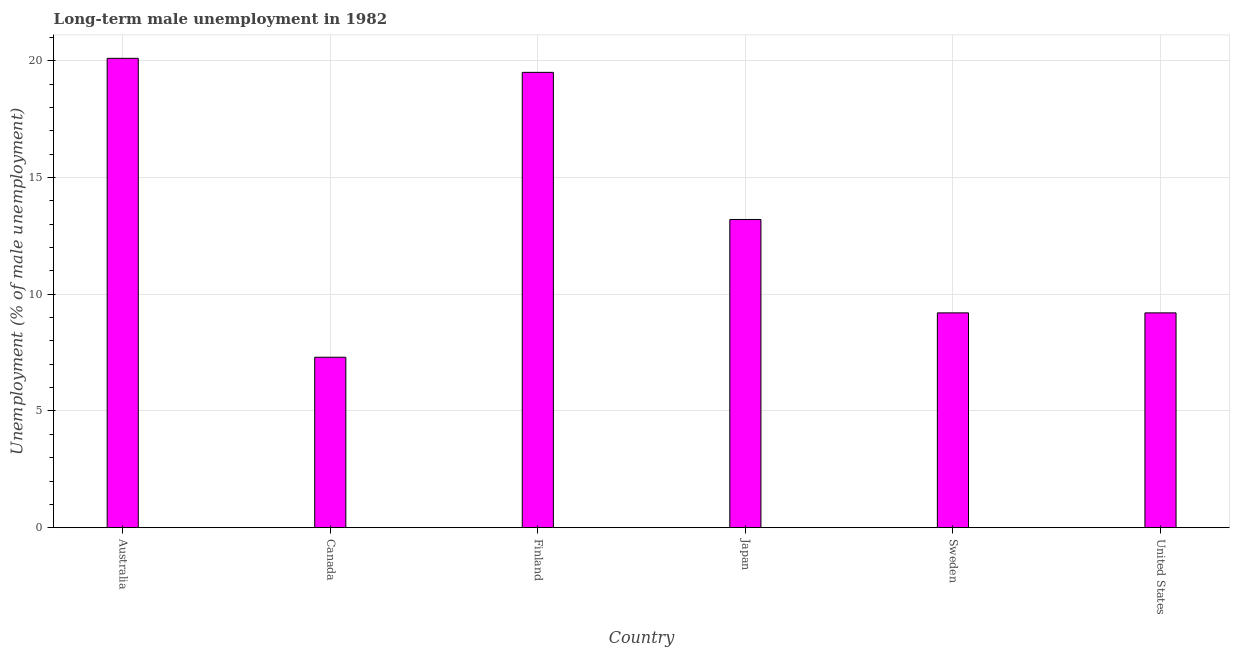What is the title of the graph?
Your answer should be compact. Long-term male unemployment in 1982. What is the label or title of the X-axis?
Provide a succinct answer. Country. What is the label or title of the Y-axis?
Your answer should be compact. Unemployment (% of male unemployment). What is the long-term male unemployment in Sweden?
Offer a terse response. 9.2. Across all countries, what is the maximum long-term male unemployment?
Provide a succinct answer. 20.1. Across all countries, what is the minimum long-term male unemployment?
Your answer should be very brief. 7.3. In which country was the long-term male unemployment maximum?
Offer a terse response. Australia. What is the sum of the long-term male unemployment?
Give a very brief answer. 78.5. What is the difference between the long-term male unemployment in Australia and Japan?
Ensure brevity in your answer.  6.9. What is the average long-term male unemployment per country?
Make the answer very short. 13.08. What is the median long-term male unemployment?
Your answer should be very brief. 11.2. What is the ratio of the long-term male unemployment in Canada to that in Japan?
Give a very brief answer. 0.55. Is the long-term male unemployment in Canada less than that in United States?
Your answer should be very brief. Yes. Is the difference between the long-term male unemployment in Australia and Finland greater than the difference between any two countries?
Offer a terse response. No. What is the difference between the highest and the second highest long-term male unemployment?
Provide a short and direct response. 0.6. Is the sum of the long-term male unemployment in Finland and Sweden greater than the maximum long-term male unemployment across all countries?
Offer a terse response. Yes. In how many countries, is the long-term male unemployment greater than the average long-term male unemployment taken over all countries?
Give a very brief answer. 3. How many bars are there?
Offer a very short reply. 6. Are all the bars in the graph horizontal?
Provide a short and direct response. No. What is the Unemployment (% of male unemployment) in Australia?
Your answer should be very brief. 20.1. What is the Unemployment (% of male unemployment) of Canada?
Keep it short and to the point. 7.3. What is the Unemployment (% of male unemployment) in Japan?
Your response must be concise. 13.2. What is the Unemployment (% of male unemployment) of Sweden?
Offer a terse response. 9.2. What is the Unemployment (% of male unemployment) of United States?
Provide a succinct answer. 9.2. What is the difference between the Unemployment (% of male unemployment) in Australia and Canada?
Make the answer very short. 12.8. What is the difference between the Unemployment (% of male unemployment) in Australia and Finland?
Provide a succinct answer. 0.6. What is the difference between the Unemployment (% of male unemployment) in Canada and Finland?
Keep it short and to the point. -12.2. What is the difference between the Unemployment (% of male unemployment) in Canada and Japan?
Make the answer very short. -5.9. What is the difference between the Unemployment (% of male unemployment) in Finland and Japan?
Offer a very short reply. 6.3. What is the difference between the Unemployment (% of male unemployment) in Finland and Sweden?
Offer a terse response. 10.3. What is the difference between the Unemployment (% of male unemployment) in Japan and Sweden?
Offer a very short reply. 4. What is the difference between the Unemployment (% of male unemployment) in Japan and United States?
Provide a short and direct response. 4. What is the ratio of the Unemployment (% of male unemployment) in Australia to that in Canada?
Provide a short and direct response. 2.75. What is the ratio of the Unemployment (% of male unemployment) in Australia to that in Finland?
Your response must be concise. 1.03. What is the ratio of the Unemployment (% of male unemployment) in Australia to that in Japan?
Your answer should be compact. 1.52. What is the ratio of the Unemployment (% of male unemployment) in Australia to that in Sweden?
Offer a terse response. 2.19. What is the ratio of the Unemployment (% of male unemployment) in Australia to that in United States?
Your answer should be compact. 2.19. What is the ratio of the Unemployment (% of male unemployment) in Canada to that in Finland?
Give a very brief answer. 0.37. What is the ratio of the Unemployment (% of male unemployment) in Canada to that in Japan?
Offer a terse response. 0.55. What is the ratio of the Unemployment (% of male unemployment) in Canada to that in Sweden?
Your answer should be compact. 0.79. What is the ratio of the Unemployment (% of male unemployment) in Canada to that in United States?
Keep it short and to the point. 0.79. What is the ratio of the Unemployment (% of male unemployment) in Finland to that in Japan?
Keep it short and to the point. 1.48. What is the ratio of the Unemployment (% of male unemployment) in Finland to that in Sweden?
Your answer should be very brief. 2.12. What is the ratio of the Unemployment (% of male unemployment) in Finland to that in United States?
Give a very brief answer. 2.12. What is the ratio of the Unemployment (% of male unemployment) in Japan to that in Sweden?
Your answer should be very brief. 1.44. What is the ratio of the Unemployment (% of male unemployment) in Japan to that in United States?
Make the answer very short. 1.44. What is the ratio of the Unemployment (% of male unemployment) in Sweden to that in United States?
Offer a terse response. 1. 